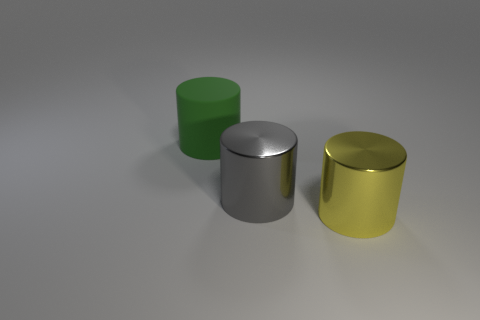Add 2 big green metal spheres. How many objects exist? 5 Subtract all gray metal things. Subtract all big purple shiny objects. How many objects are left? 2 Add 2 green matte cylinders. How many green matte cylinders are left? 3 Add 2 tiny shiny objects. How many tiny shiny objects exist? 2 Subtract 0 brown cylinders. How many objects are left? 3 